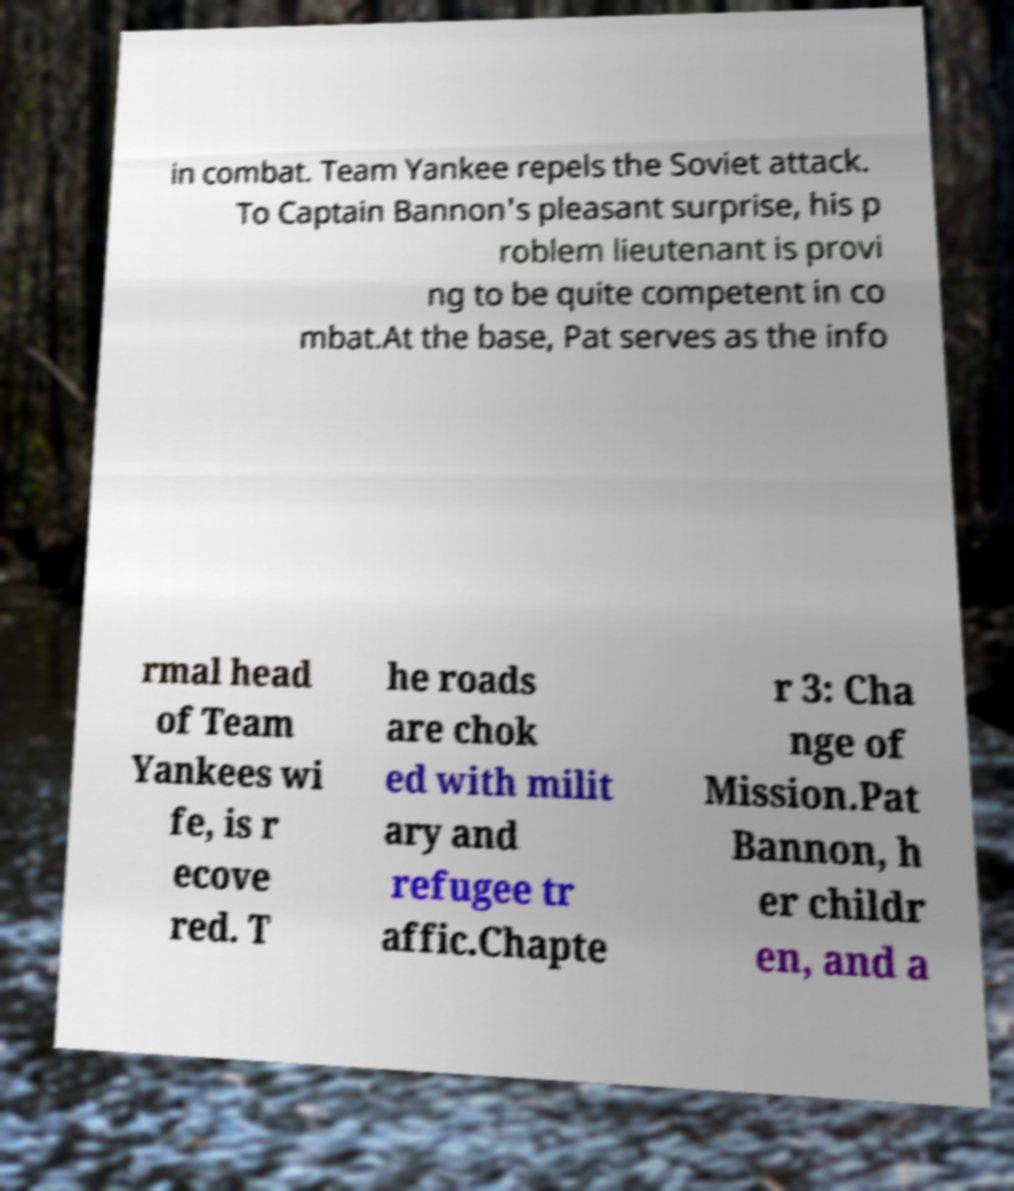Please identify and transcribe the text found in this image. in combat. Team Yankee repels the Soviet attack. To Captain Bannon's pleasant surprise, his p roblem lieutenant is provi ng to be quite competent in co mbat.At the base, Pat serves as the info rmal head of Team Yankees wi fe, is r ecove red. T he roads are chok ed with milit ary and refugee tr affic.Chapte r 3: Cha nge of Mission.Pat Bannon, h er childr en, and a 